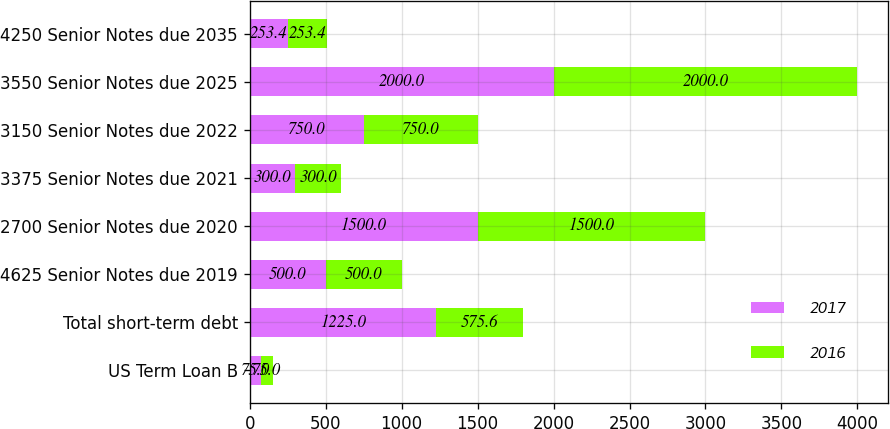Convert chart. <chart><loc_0><loc_0><loc_500><loc_500><stacked_bar_chart><ecel><fcel>US Term Loan B<fcel>Total short-term debt<fcel>4625 Senior Notes due 2019<fcel>2700 Senior Notes due 2020<fcel>3375 Senior Notes due 2021<fcel>3150 Senior Notes due 2022<fcel>3550 Senior Notes due 2025<fcel>4250 Senior Notes due 2035<nl><fcel>2017<fcel>75<fcel>1225<fcel>500<fcel>1500<fcel>300<fcel>750<fcel>2000<fcel>253.4<nl><fcel>2016<fcel>75<fcel>575.6<fcel>500<fcel>1500<fcel>300<fcel>750<fcel>2000<fcel>253.4<nl></chart> 